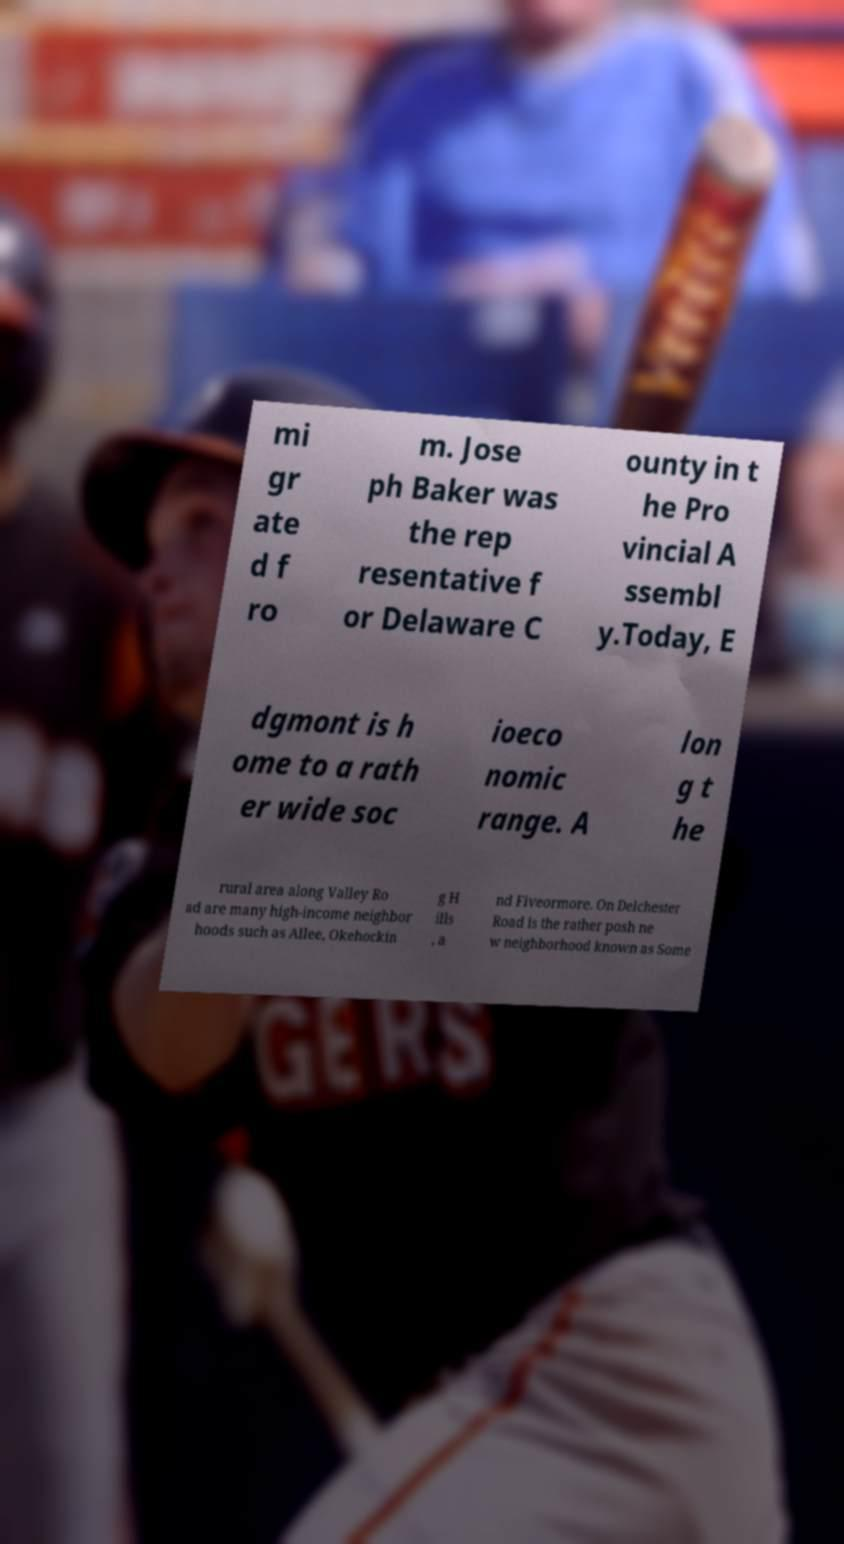What messages or text are displayed in this image? I need them in a readable, typed format. mi gr ate d f ro m. Jose ph Baker was the rep resentative f or Delaware C ounty in t he Pro vincial A ssembl y.Today, E dgmont is h ome to a rath er wide soc ioeco nomic range. A lon g t he rural area along Valley Ro ad are many high-income neighbor hoods such as Allee, Okehockin g H ills , a nd Fiveormore. On Delchester Road is the rather posh ne w neighborhood known as Some 